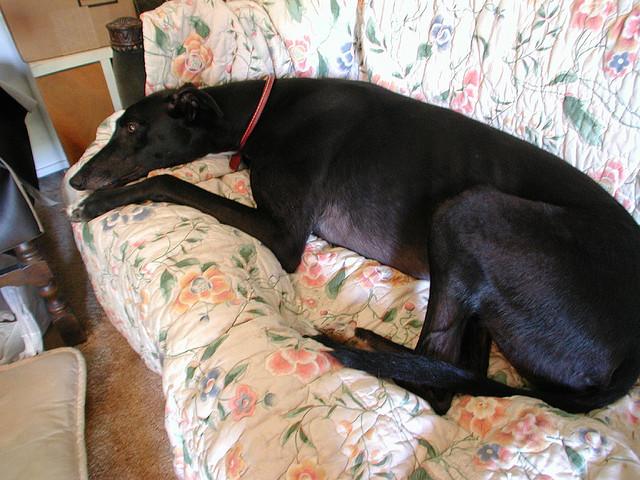What color is the dog's collar?
Be succinct. Red. What color is the dog?
Give a very brief answer. Black. Is the dog awake?
Short answer required. Yes. 